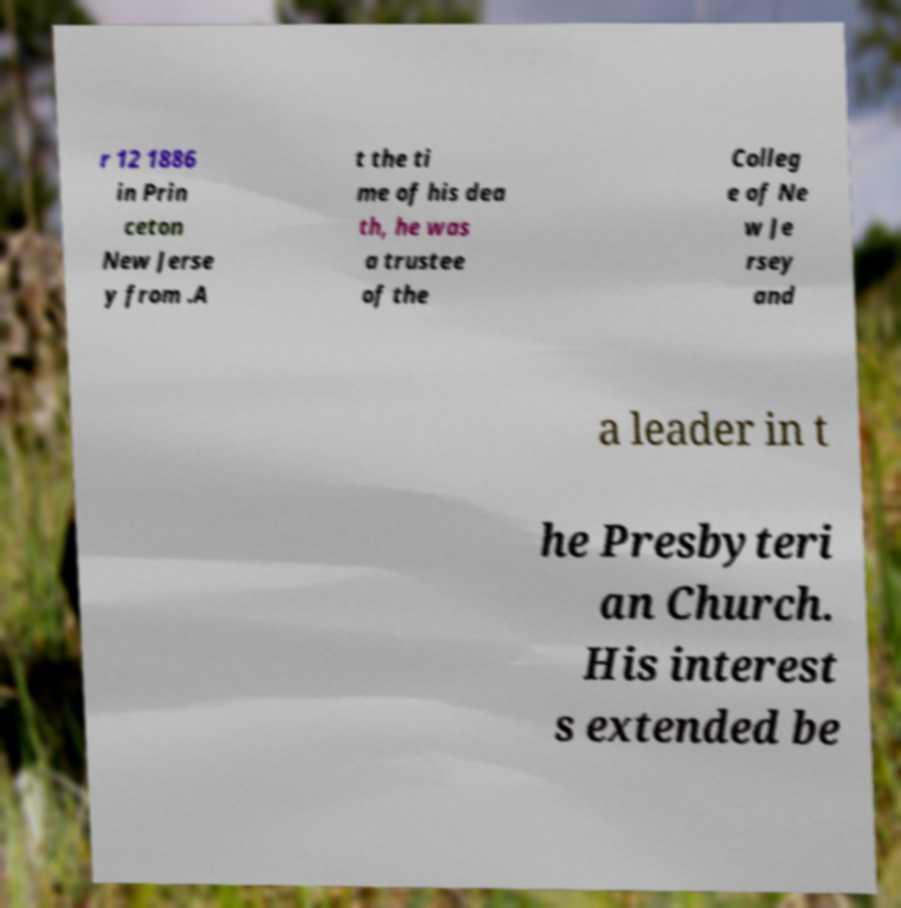Could you extract and type out the text from this image? r 12 1886 in Prin ceton New Jerse y from .A t the ti me of his dea th, he was a trustee of the Colleg e of Ne w Je rsey and a leader in t he Presbyteri an Church. His interest s extended be 